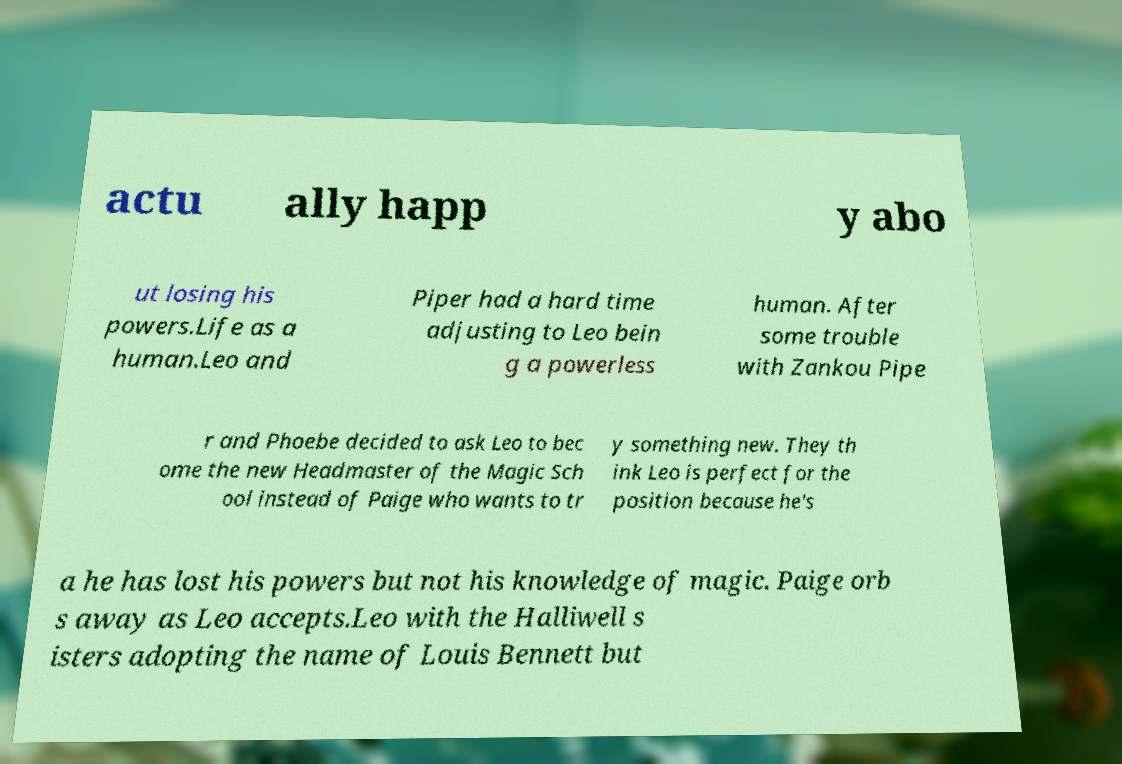Please read and relay the text visible in this image. What does it say? actu ally happ y abo ut losing his powers.Life as a human.Leo and Piper had a hard time adjusting to Leo bein g a powerless human. After some trouble with Zankou Pipe r and Phoebe decided to ask Leo to bec ome the new Headmaster of the Magic Sch ool instead of Paige who wants to tr y something new. They th ink Leo is perfect for the position because he's a he has lost his powers but not his knowledge of magic. Paige orb s away as Leo accepts.Leo with the Halliwell s isters adopting the name of Louis Bennett but 